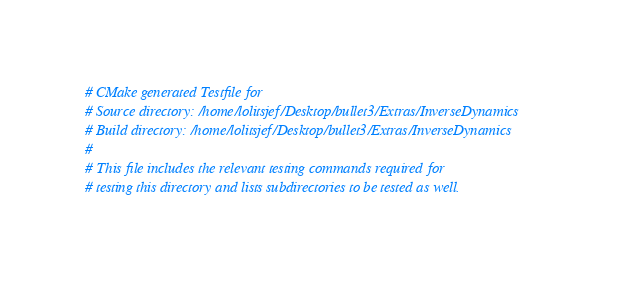Convert code to text. <code><loc_0><loc_0><loc_500><loc_500><_CMake_># CMake generated Testfile for 
# Source directory: /home/lolitsjef/Desktop/bullet3/Extras/InverseDynamics
# Build directory: /home/lolitsjef/Desktop/bullet3/Extras/InverseDynamics
# 
# This file includes the relevant testing commands required for 
# testing this directory and lists subdirectories to be tested as well.
</code> 